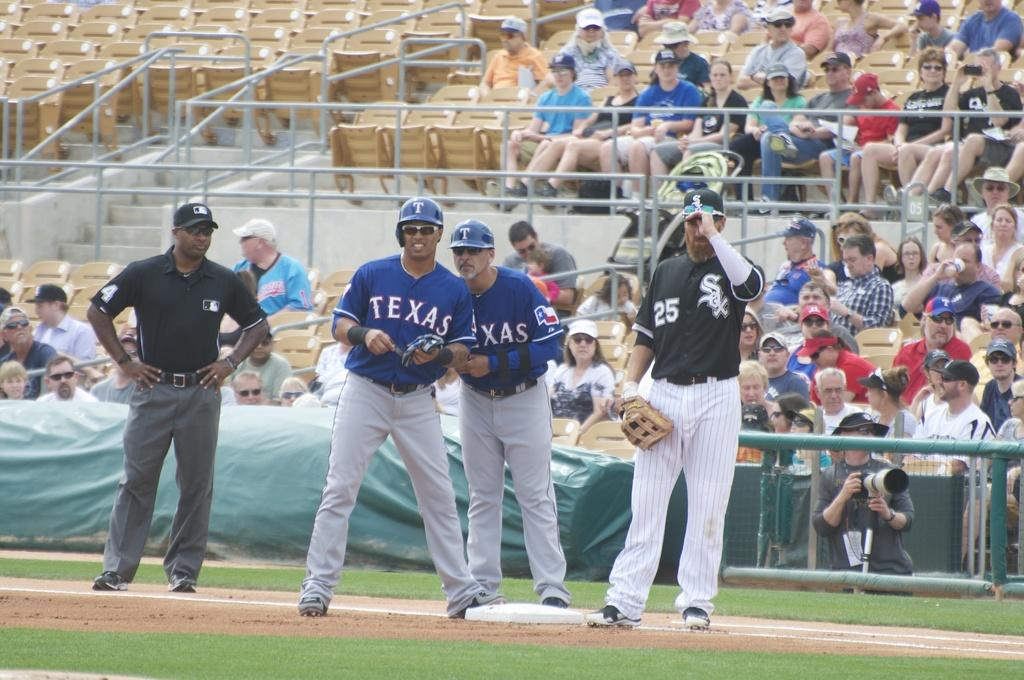Provide a one-sentence caption for the provided image. Two Texas teammates wearing sunglasses talk at the base. 